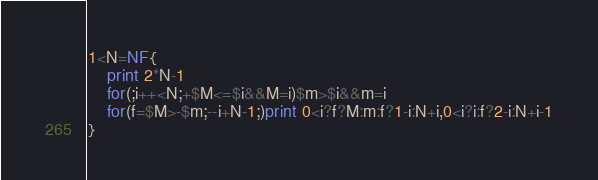Convert code to text. <code><loc_0><loc_0><loc_500><loc_500><_Awk_>1<N=NF{
	print 2*N-1
	for(;i++<N;+$M<=$i&&M=i)$m>$i&&m=i
	for(f=$M>-$m;--i+N-1;)print 0<i?f?M:m:f?1-i:N+i,0<i?i:f?2-i:N+i-1
}</code> 